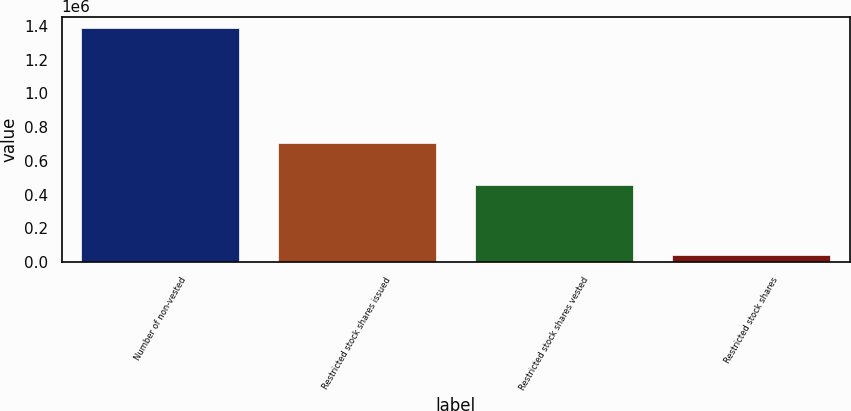Convert chart to OTSL. <chart><loc_0><loc_0><loc_500><loc_500><bar_chart><fcel>Number of non-vested<fcel>Restricted stock shares issued<fcel>Restricted stock shares vested<fcel>Restricted stock shares<nl><fcel>1.38683e+06<fcel>703620<fcel>458750<fcel>41700<nl></chart> 